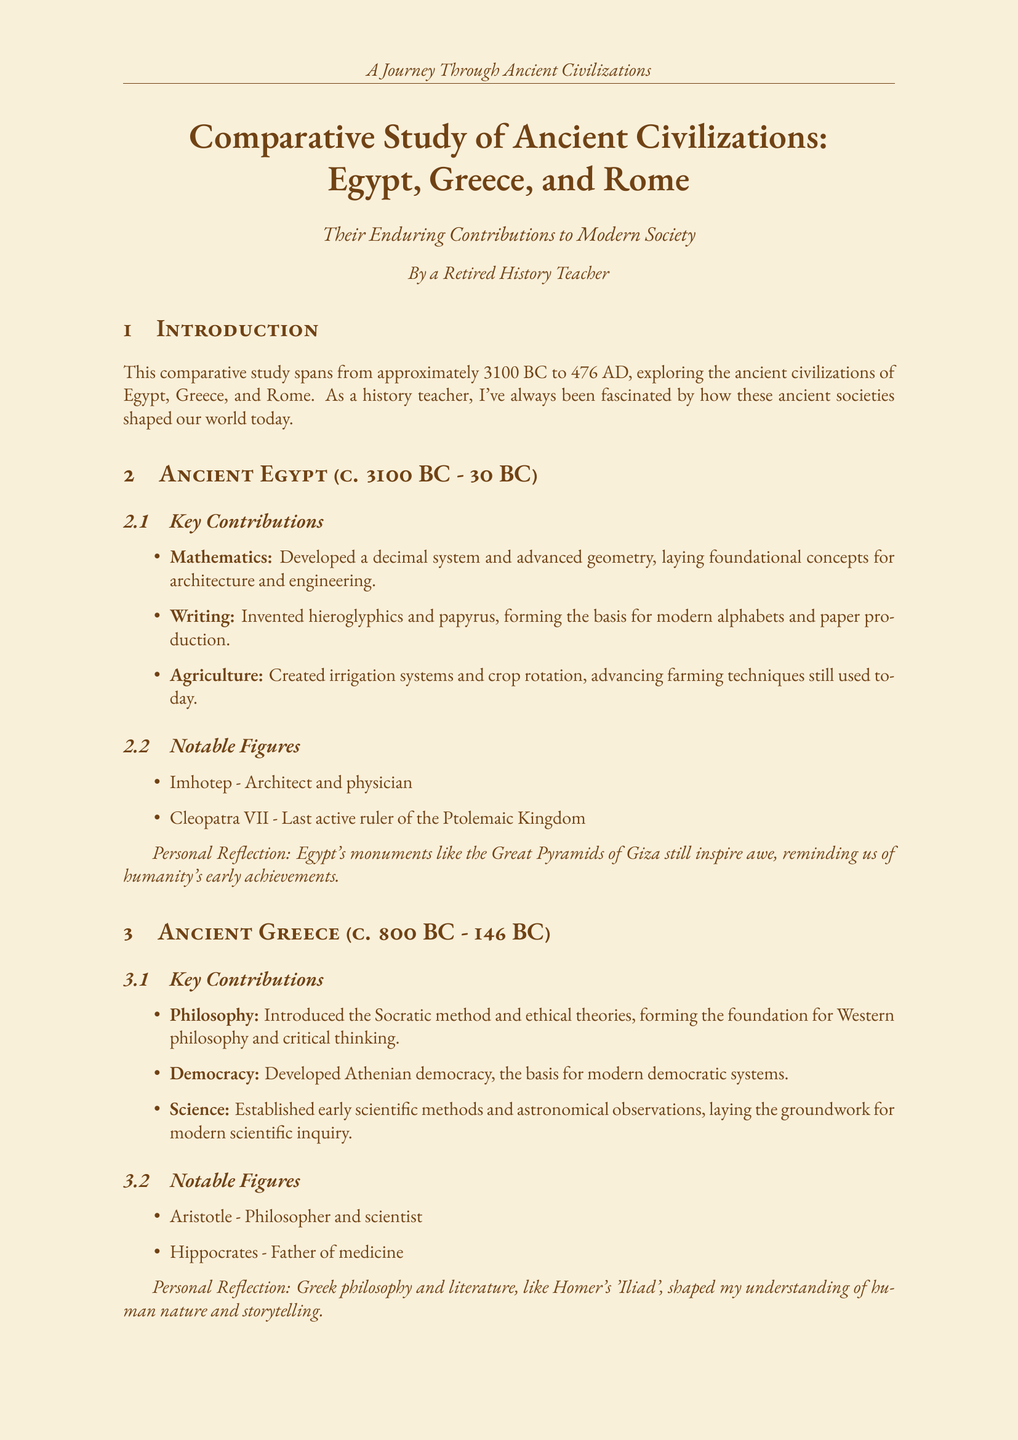What time period does the study cover? The study spans from approximately 3100 BC to 476 AD, covering the timeline of ancient Egypt, Greece, and Rome.
Answer: approximately 3100 BC to 476 AD Who is considered the father of medicine? Hippocrates is noted in the document as the "Father of medicine," highlighting his significant contributions.
Answer: Hippocrates What major legal system is founded on Roman contributions? The document mentions Roman law and jurisprudence as foundational for many modern systems, making it a significant point.
Answer: modern legal systems Which civilization emphasized the afterlife and preservation? The unique aspect of ancient Egypt noted in the document emphasizes its focus on the afterlife.
Answer: Egypt What type of democracy did Greece develop? The document states that Greece developed Athenian democracy, marking its contribution to modern governance.
Answer: Athenian democracy What notable figure is associated with Ancient Rome? Julius Caesar is mentioned in the document as a notable figure from ancient Rome, significant in its historical context.
Answer: Julius Caesar What fundamental concept of science was established by Greece? Greece is credited with establishing the early scientific method, which laid the groundwork for subsequent scientific inquiry.
Answer: early scientific method Which agricultural innovation did Egypt develop? The document lists irrigation systems and crop rotation as significant contributions to agriculture from ancient Egypt.
Answer: irrigation systems and crop rotation What was a shared trait among Egypt, Greece, and Rome? The document notes that advanced agricultural techniques were a common feature shared across these civilizations.
Answer: Advanced agricultural techniques 